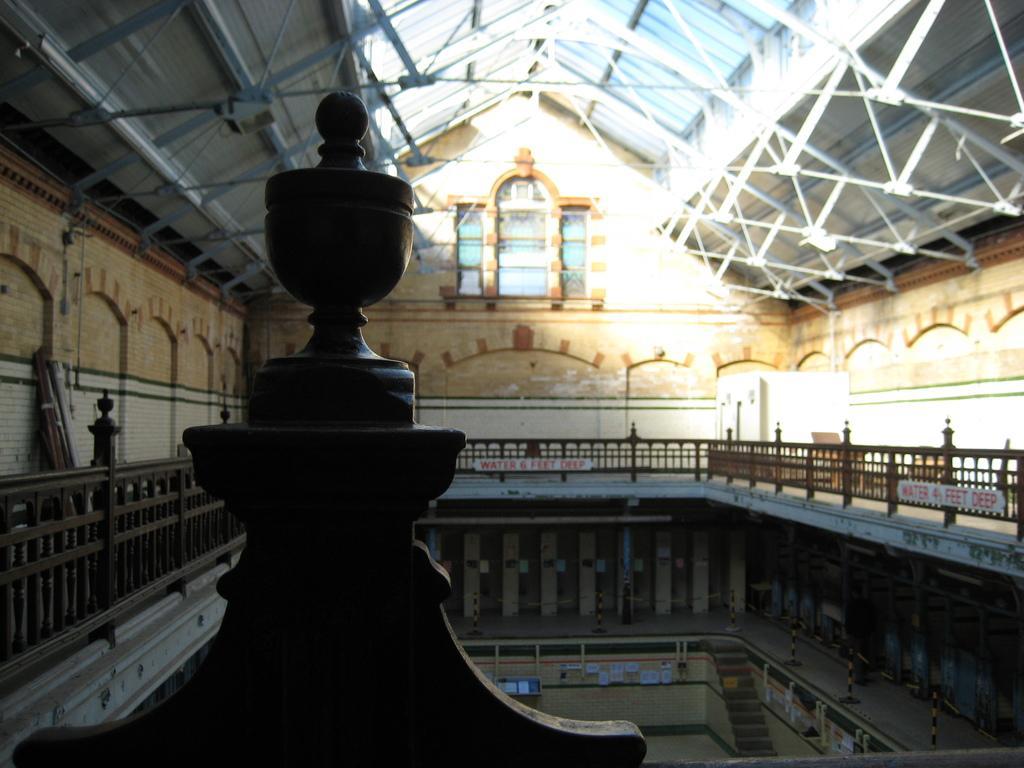Please provide a concise description of this image. The image is taken inside the building. In the center can see railings. In the background there is a window. At the top there is a roof. 